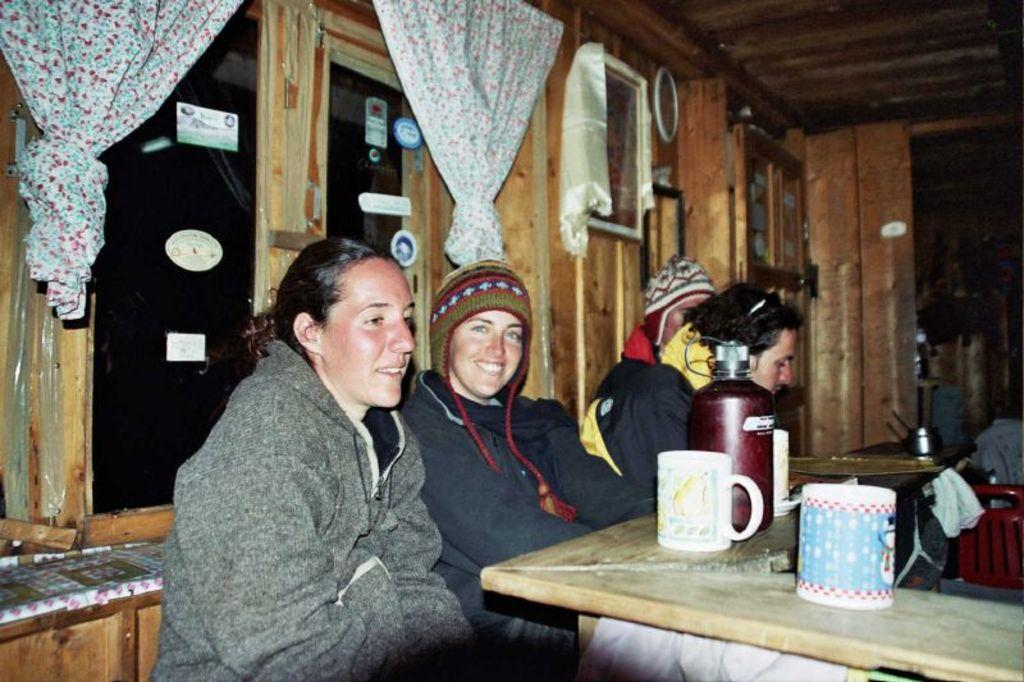What are the people in the image doing? The people in the image are sitting in front of a table. What objects can be seen on the table? There is a flask and cups on the table. Is there any indication of a window in the background? Yes, there is a curtain in the background, likely associated with a window. What type of plants can be seen growing on the table in the image? There are no plants visible on the table in the image. 